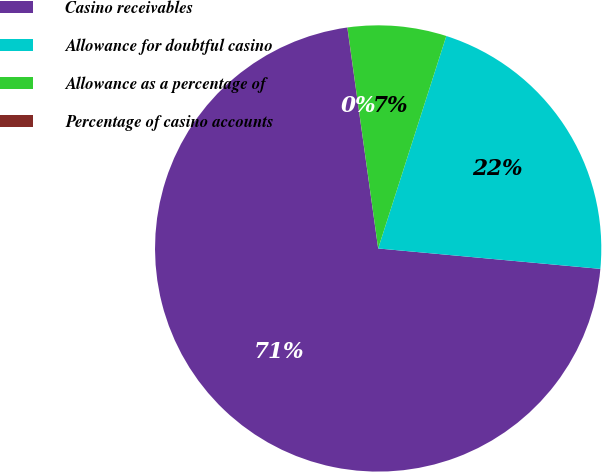<chart> <loc_0><loc_0><loc_500><loc_500><pie_chart><fcel>Casino receivables<fcel>Allowance for doubtful casino<fcel>Allowance as a percentage of<fcel>Percentage of casino accounts<nl><fcel>71.34%<fcel>21.52%<fcel>7.14%<fcel>0.01%<nl></chart> 